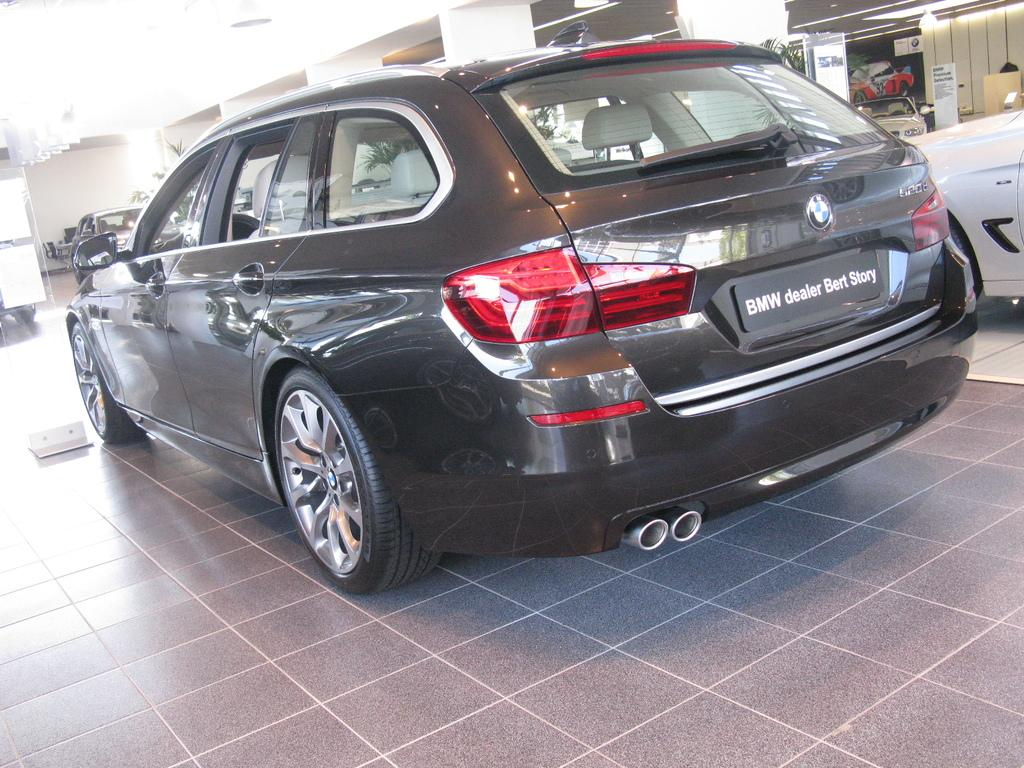What type of vehicles can be seen on the road in the image? There are motor vehicles on the road in the image. What can be seen in the background of the image? There are electric lights and plants visible in the background of the image. What language is being spoken by the plants in the image? There are no plants speaking any language in the image, as plants do not have the ability to speak. 